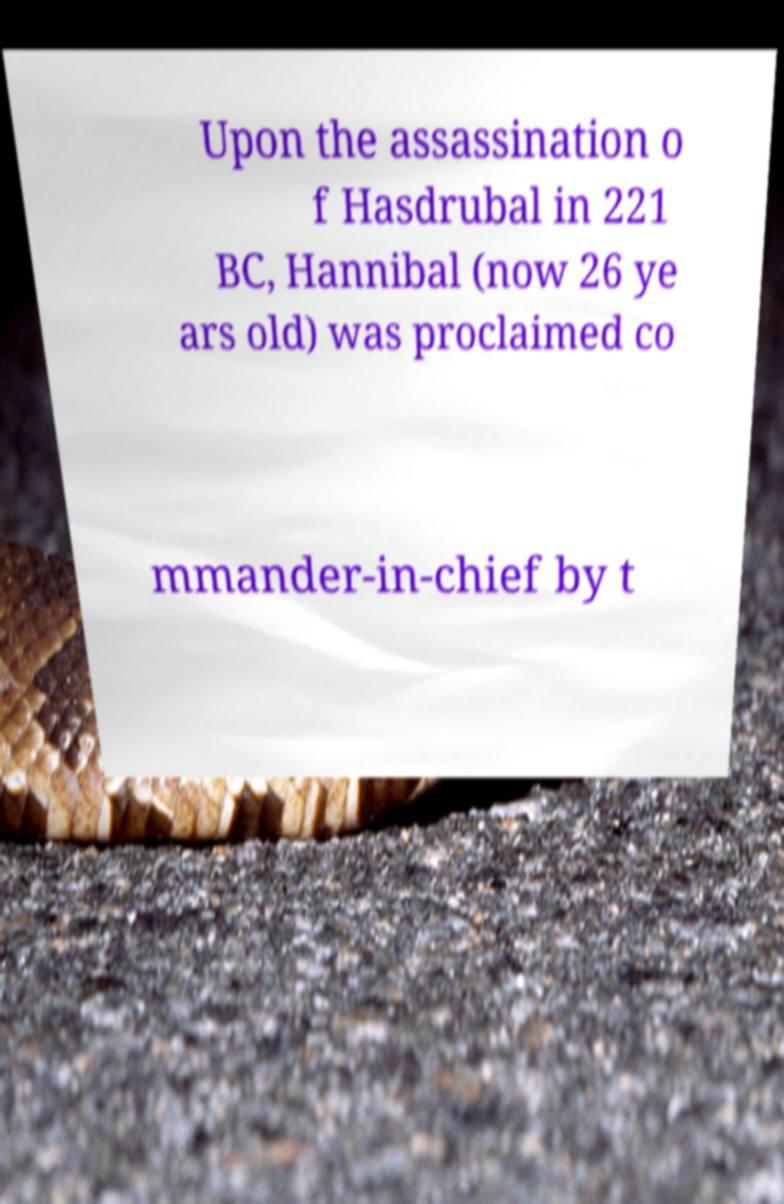What messages or text are displayed in this image? I need them in a readable, typed format. Upon the assassination o f Hasdrubal in 221 BC, Hannibal (now 26 ye ars old) was proclaimed co mmander-in-chief by t 